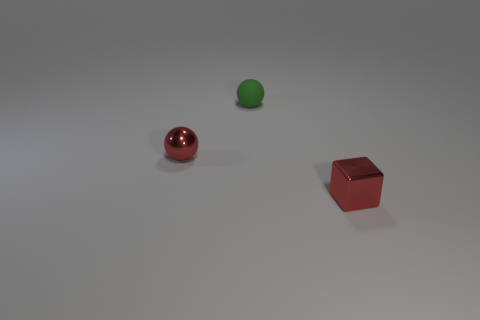What number of other things are the same size as the metal cube?
Offer a very short reply. 2. What is the shape of the small red object that is on the right side of the sphere that is right of the ball in front of the matte ball?
Ensure brevity in your answer.  Cube. What number of red objects are small shiny balls or small shiny cubes?
Provide a short and direct response. 2. There is a tiny metal object in front of the red shiny ball; how many small red metallic objects are to the left of it?
Ensure brevity in your answer.  1. Is there anything else of the same color as the tiny matte thing?
Your response must be concise. No. What is the shape of the tiny red thing that is made of the same material as the small block?
Offer a terse response. Sphere. Is the color of the metallic block the same as the small metal sphere?
Offer a very short reply. Yes. Are the small thing that is to the left of the green thing and the small red object that is to the right of the tiny shiny sphere made of the same material?
Your answer should be very brief. Yes. How many things are small matte things or tiny things in front of the green object?
Make the answer very short. 3. Is there any other thing that is the same material as the green thing?
Keep it short and to the point. No. 